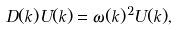<formula> <loc_0><loc_0><loc_500><loc_500>\ D ( k ) U ( k ) = \omega ( k ) ^ { 2 } U ( k ) ,</formula> 